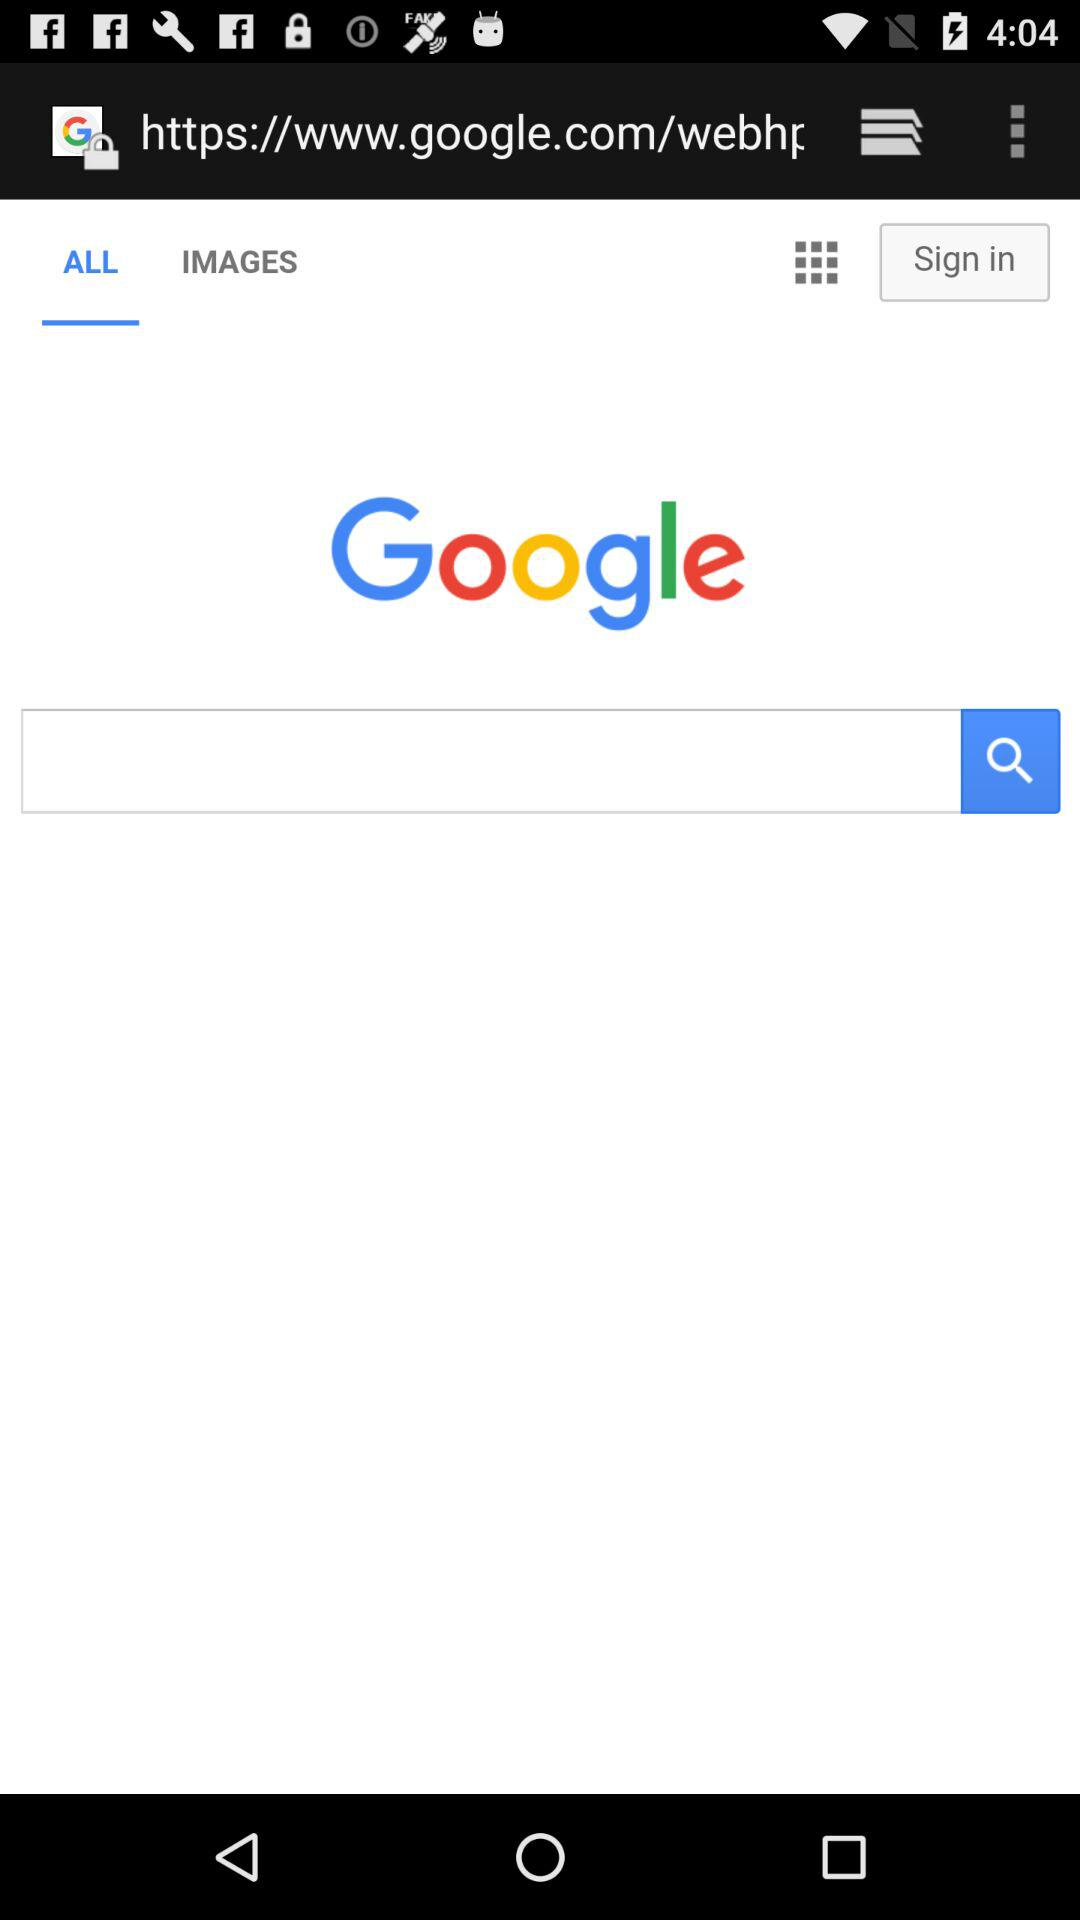Which tab am I on? You are on the "ALL" tab. 